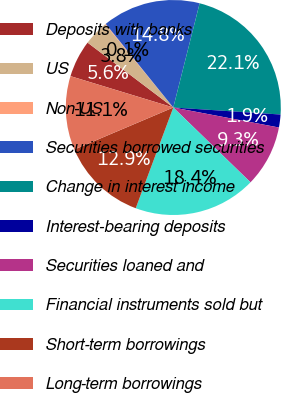Convert chart to OTSL. <chart><loc_0><loc_0><loc_500><loc_500><pie_chart><fcel>Deposits with banks<fcel>US<fcel>Non-US<fcel>Securities borrowed securities<fcel>Change in interest income<fcel>Interest-bearing deposits<fcel>Securities loaned and<fcel>Financial instruments sold but<fcel>Short-term borrowings<fcel>Long-term borrowings<nl><fcel>5.6%<fcel>3.77%<fcel>0.1%<fcel>14.76%<fcel>22.1%<fcel>1.94%<fcel>9.27%<fcel>18.43%<fcel>12.93%<fcel>11.1%<nl></chart> 